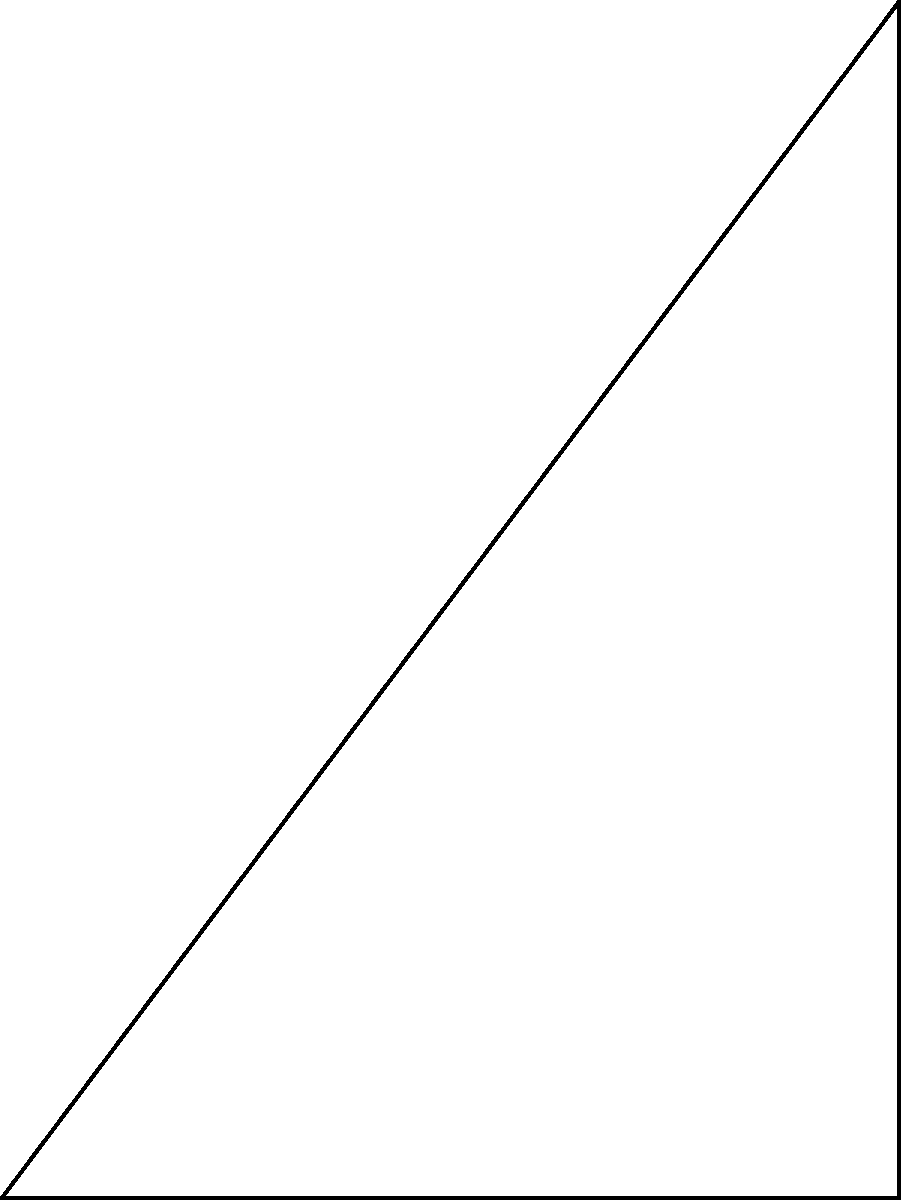You're setting up a crane to lift a heavy load on a construction site. The crane's base is at point O, and the load is located 30 meters away at point A. The crane's boom can extend up to 50 meters. What angle $\theta$ should the crane's boom make with the ground to lift the load while keeping the boom as short as possible? Let's approach this step-by-step:

1) We have a right triangle OAB, where:
   - OA is the distance from the crane to the load (30 m)
   - OB is the crane's boom
   - AB is the height the load needs to be lifted

2) We want to minimize the length of OB (the boom) while still reaching the load.

3) The shortest possible boom length that can reach the load will form a right angle with BA. This is because the right angle creates the shortest hypotenuse for a given base and height.

4) In this optimal triangle:
   - OA = 30 m (given)
   - OB = minimum boom length (unknown)
   - AB = height (unknown)

5) We can use the Pythagorean theorem:
   $OB^2 = OA^2 + AB^2$

6) We're told the boom can extend up to 50 m, so:
   $OB^2 = 30^2 + AB^2 = 50^2$

7) Solving for AB:
   $AB^2 = 50^2 - 30^2 = 2500 - 900 = 1600$
   $AB = \sqrt{1600} = 40$ m

8) Now we have a 30-40-50 right triangle. We can find $\theta$ using trigonometry:

   $\tan(\theta) = \frac{opposite}{adjacent} = \frac{AB}{OA} = \frac{40}{30} = \frac{4}{3}$

9) Therefore:
   $\theta = \arctan(\frac{4}{3}) \approx 53.13°$
Answer: $53.13°$ 